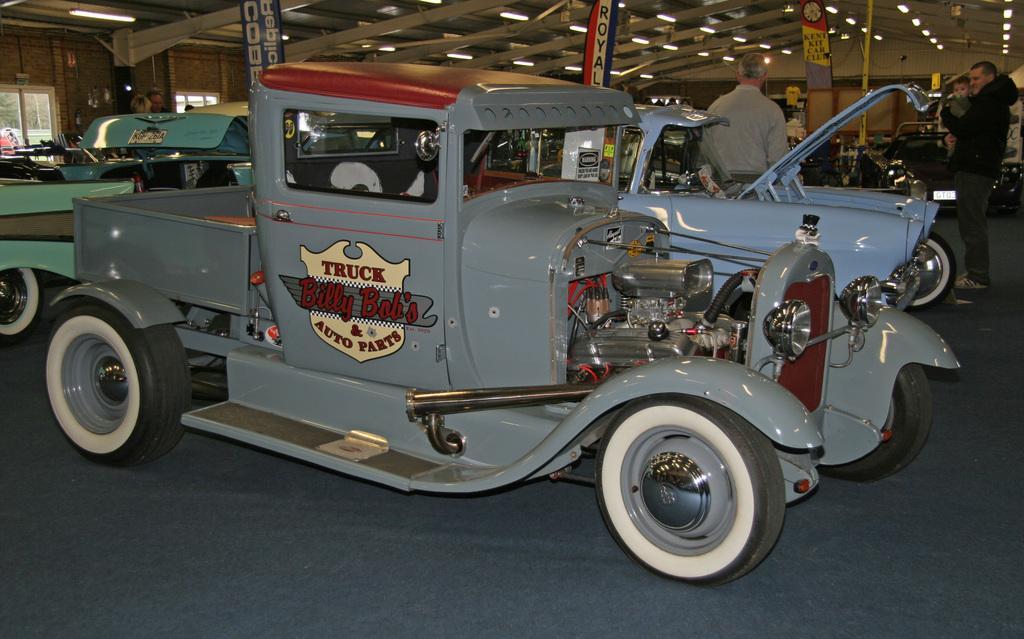Describe this image in one or two sentences. In this image, I can see the antique cars and few people standing on the floor. At the top of the image, I can see the lights and banners hanging. On the left side of the image, there are windows. 